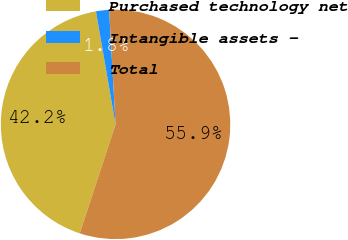<chart> <loc_0><loc_0><loc_500><loc_500><pie_chart><fcel>Purchased technology net<fcel>Intangible assets -<fcel>Total<nl><fcel>42.22%<fcel>1.84%<fcel>55.95%<nl></chart> 